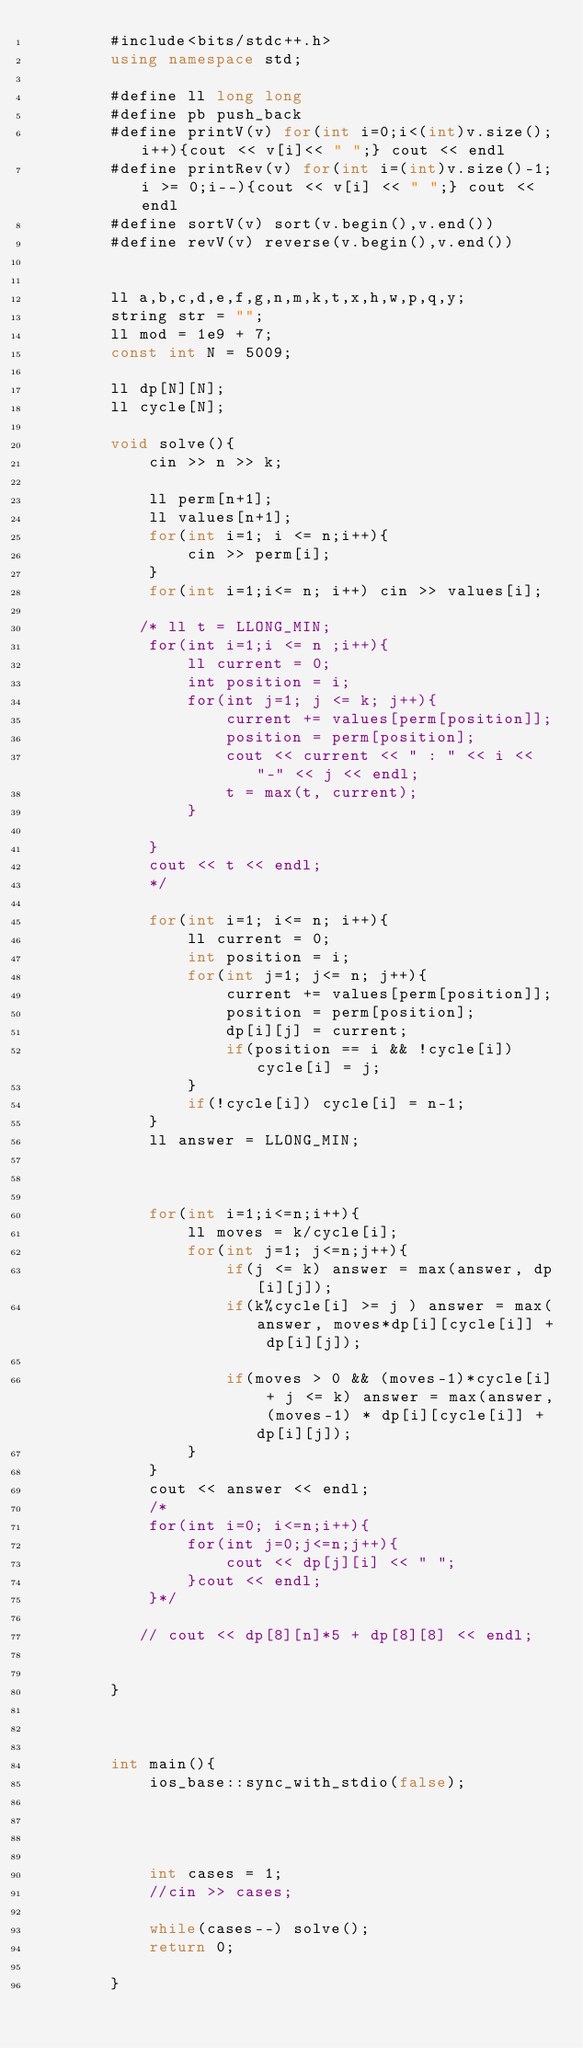Convert code to text. <code><loc_0><loc_0><loc_500><loc_500><_C++_>        #include<bits/stdc++.h>
        using namespace std;

        #define ll long long
        #define pb push_back
        #define printV(v) for(int i=0;i<(int)v.size();i++){cout << v[i]<< " ";} cout << endl
        #define printRev(v) for(int i=(int)v.size()-1;i >= 0;i--){cout << v[i] << " ";} cout << endl
        #define sortV(v) sort(v.begin(),v.end())
        #define revV(v) reverse(v.begin(),v.end())
    

        ll a,b,c,d,e,f,g,n,m,k,t,x,h,w,p,q,y;
        string str = "";
        ll mod = 1e9 + 7;
        const int N = 5009;
      
        ll dp[N][N];
        ll cycle[N];
        
        void solve(){
            cin >> n >> k;
            
            ll perm[n+1];
            ll values[n+1];
            for(int i=1; i <= n;i++){
                cin >> perm[i];
            }
            for(int i=1;i<= n; i++) cin >> values[i];
            
           /* ll t = LLONG_MIN;
            for(int i=1;i <= n ;i++){
                ll current = 0;
                int position = i;
                for(int j=1; j <= k; j++){
                    current += values[perm[position]];
                    position = perm[position];
                    cout << current << " : " << i << "-" << j << endl;
                    t = max(t, current); 
                }
                
            }
            cout << t << endl;
            */
            
            for(int i=1; i<= n; i++){
                ll current = 0;
                int position = i;
                for(int j=1; j<= n; j++){
                    current += values[perm[position]];
                    position = perm[position];
                    dp[i][j] = current;
                    if(position == i && !cycle[i]) cycle[i] = j;  
                }
                if(!cycle[i]) cycle[i] = n-1;
            }
            ll answer = LLONG_MIN;
            
            
            
            for(int i=1;i<=n;i++){
                ll moves = k/cycle[i];
                for(int j=1; j<=n;j++){
                    if(j <= k) answer = max(answer, dp[i][j]);
                    if(k%cycle[i] >= j ) answer = max(answer, moves*dp[i][cycle[i]] + dp[i][j]);
                    
                    if(moves > 0 && (moves-1)*cycle[i] + j <= k) answer = max(answer, (moves-1) * dp[i][cycle[i]] + dp[i][j]);
                }
            }
            cout << answer << endl;
            /*
            for(int i=0; i<=n;i++){
                for(int j=0;j<=n;j++){
                    cout << dp[j][i] << " ";
                }cout << endl;
            }*/

           // cout << dp[8][n]*5 + dp[8][8] << endl;
        

        }



        int main(){
            ios_base::sync_with_stdio(false);

            


            int cases = 1;
            //cin >> cases;

            while(cases--) solve();
            return 0;

        }</code> 